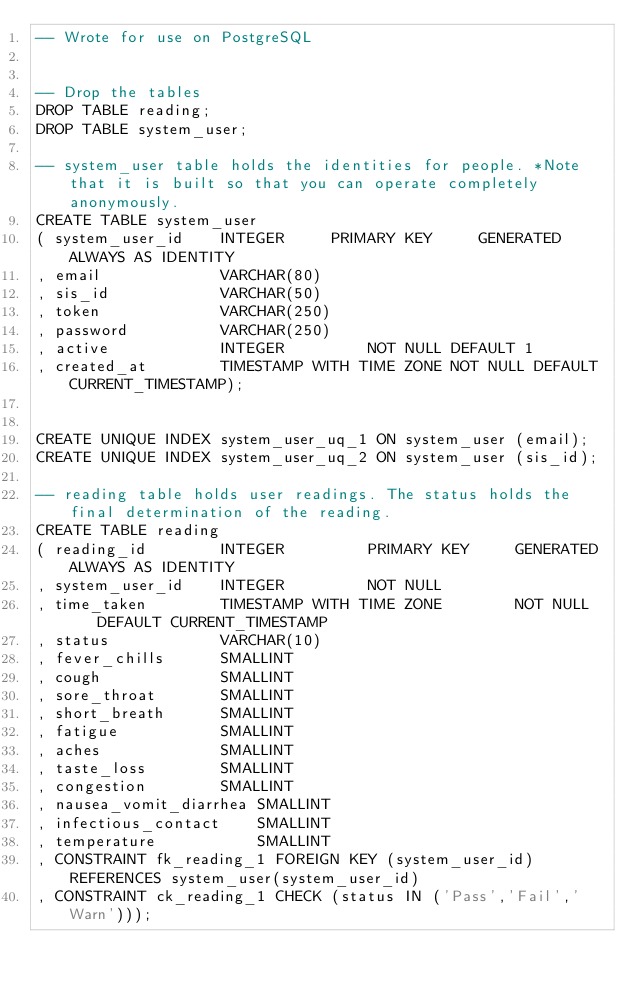<code> <loc_0><loc_0><loc_500><loc_500><_SQL_>-- Wrote for use on PostgreSQL


-- Drop the tables
DROP TABLE reading;
DROP TABLE system_user;

-- system_user table holds the identities for people. *Note that it is built so that you can operate completely anonymously.
CREATE TABLE system_user 
( system_user_id 	INTEGER		PRIMARY KEY 	GENERATED ALWAYS AS IDENTITY
, email 			VARCHAR(80)
, sis_id 			VARCHAR(50)
, token 			VARCHAR(250)
, password			VARCHAR(250)
, active 			INTEGER			NOT NULL DEFAULT 1
, created_at		TIMESTAMP WITH TIME ZONE NOT NULL DEFAULT CURRENT_TIMESTAMP);


CREATE UNIQUE INDEX system_user_uq_1 ON system_user (email);
CREATE UNIQUE INDEX system_user_uq_2 ON system_user (sis_id);

-- reading table holds user readings. The status holds the final determination of the reading.
CREATE TABLE reading 
( reading_id 		INTEGER 		PRIMARY KEY 	GENERATED ALWAYS AS IDENTITY 
, system_user_id	INTEGER			NOT NULL 
, time_taken 		TIMESTAMP WITH TIME ZONE 		NOT NULL    DEFAULT CURRENT_TIMESTAMP
, status 			VARCHAR(10) 
, fever_chills		SMALLINT 
, cough				SMALLINT
, sore_throat		SMALLINT 
, short_breath		SMALLINT 
, fatigue			SMALLINT 
, aches 			SMALLINT 
, taste_loss		SMALLINT 
, congestion 		SMALLINT 
, nausea_vomit_diarrhea	SMALLINT
, infectious_contact	SMALLINT 
, temperature			SMALLINT 
, CONSTRAINT fk_reading_1 FOREIGN KEY (system_user_id) REFERENCES system_user(system_user_id) 
, CONSTRAINT ck_reading_1 CHECK (status IN ('Pass','Fail','Warn')));</code> 